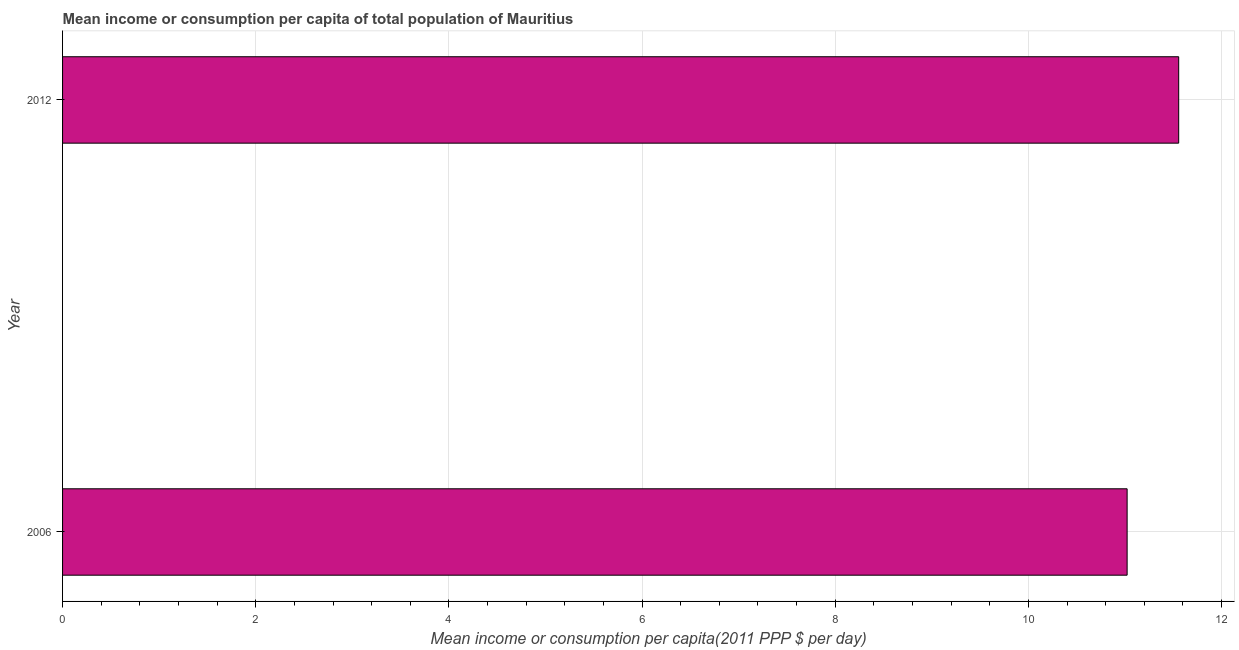Does the graph contain any zero values?
Ensure brevity in your answer.  No. Does the graph contain grids?
Keep it short and to the point. Yes. What is the title of the graph?
Your answer should be compact. Mean income or consumption per capita of total population of Mauritius. What is the label or title of the X-axis?
Provide a short and direct response. Mean income or consumption per capita(2011 PPP $ per day). What is the label or title of the Y-axis?
Your answer should be compact. Year. What is the mean income or consumption in 2006?
Your response must be concise. 11.02. Across all years, what is the maximum mean income or consumption?
Provide a short and direct response. 11.56. Across all years, what is the minimum mean income or consumption?
Offer a terse response. 11.02. In which year was the mean income or consumption maximum?
Your answer should be very brief. 2012. In which year was the mean income or consumption minimum?
Keep it short and to the point. 2006. What is the sum of the mean income or consumption?
Offer a terse response. 22.58. What is the difference between the mean income or consumption in 2006 and 2012?
Make the answer very short. -0.53. What is the average mean income or consumption per year?
Keep it short and to the point. 11.29. What is the median mean income or consumption?
Ensure brevity in your answer.  11.29. Do a majority of the years between 2006 and 2012 (inclusive) have mean income or consumption greater than 1.2 $?
Your response must be concise. Yes. What is the ratio of the mean income or consumption in 2006 to that in 2012?
Your answer should be compact. 0.95. How many bars are there?
Offer a terse response. 2. Are all the bars in the graph horizontal?
Provide a succinct answer. Yes. What is the Mean income or consumption per capita(2011 PPP $ per day) of 2006?
Make the answer very short. 11.02. What is the Mean income or consumption per capita(2011 PPP $ per day) of 2012?
Make the answer very short. 11.56. What is the difference between the Mean income or consumption per capita(2011 PPP $ per day) in 2006 and 2012?
Your answer should be compact. -0.53. What is the ratio of the Mean income or consumption per capita(2011 PPP $ per day) in 2006 to that in 2012?
Keep it short and to the point. 0.95. 